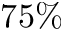<formula> <loc_0><loc_0><loc_500><loc_500>7 5 \%</formula> 